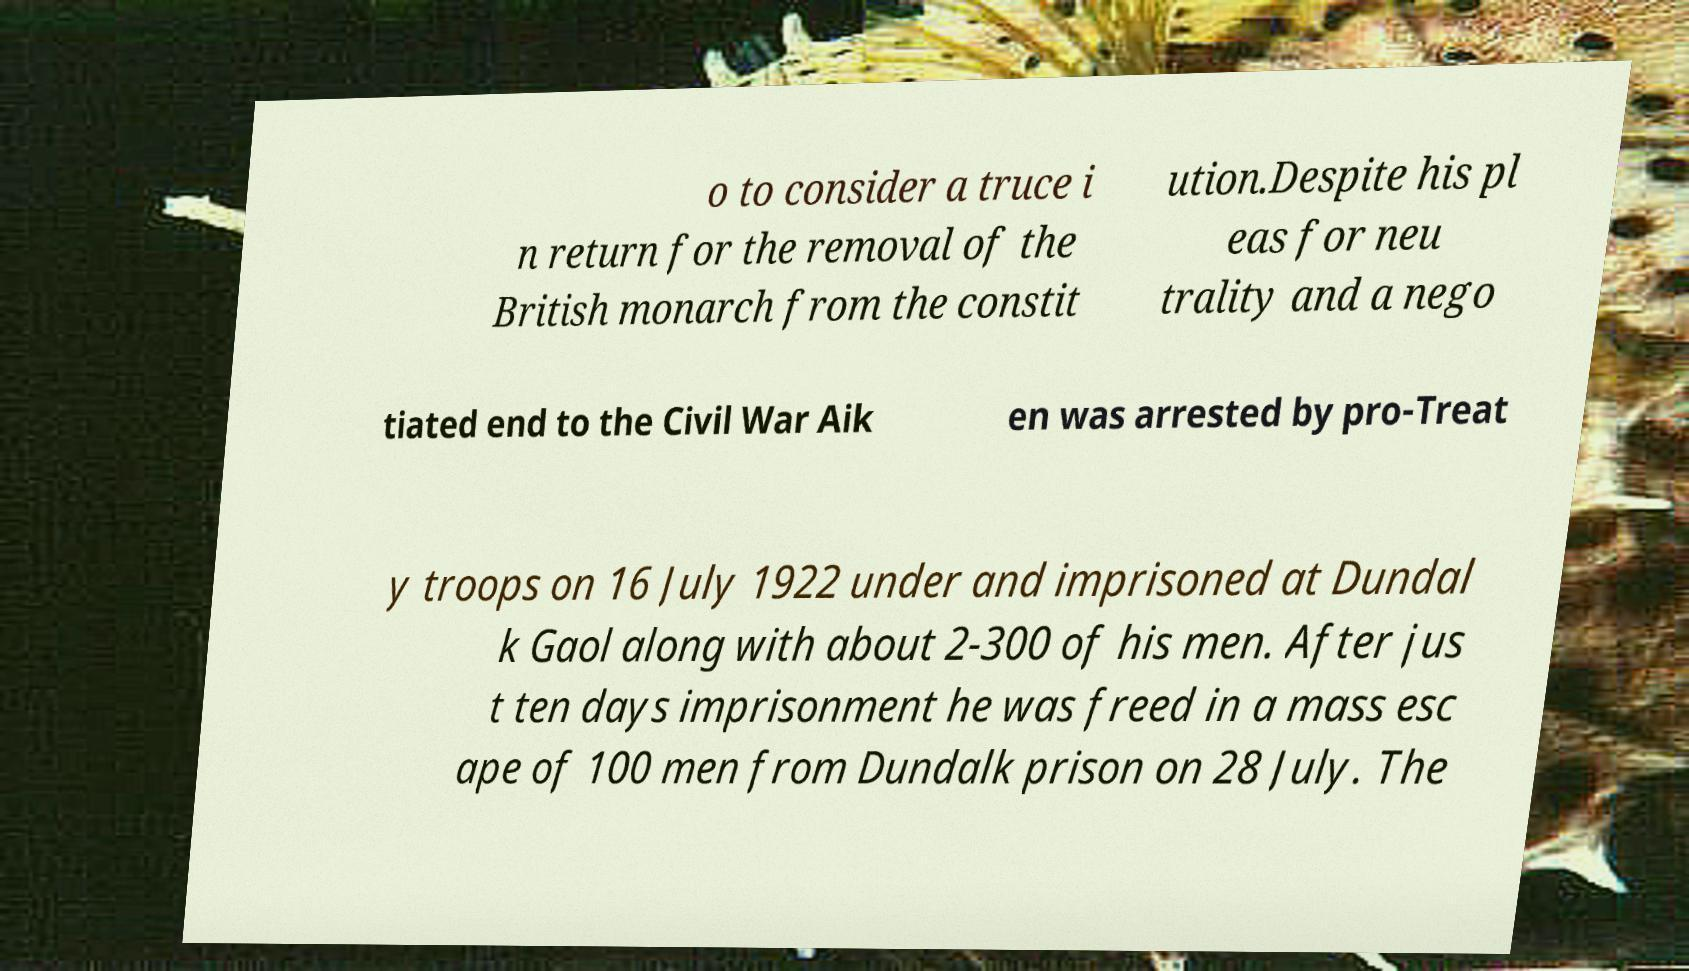For documentation purposes, I need the text within this image transcribed. Could you provide that? o to consider a truce i n return for the removal of the British monarch from the constit ution.Despite his pl eas for neu trality and a nego tiated end to the Civil War Aik en was arrested by pro-Treat y troops on 16 July 1922 under and imprisoned at Dundal k Gaol along with about 2-300 of his men. After jus t ten days imprisonment he was freed in a mass esc ape of 100 men from Dundalk prison on 28 July. The 